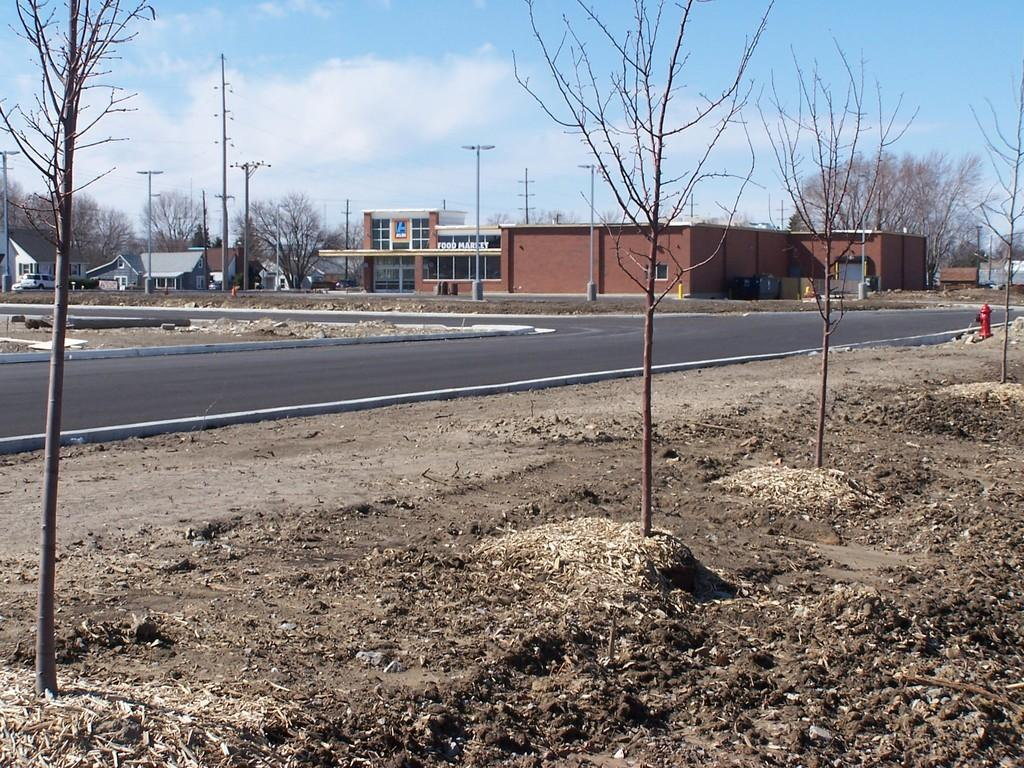What type of vegetation is present on the ground in the image? There are trees on the ground in the image. What type of transportation infrastructure can be seen in the image? There is a road in the image. What type of utility infrastructure is present in the image? There is a hydrant in the image. What type of man-made structures are visible in the image? There are buildings in the image. What type of vertical structures are present in the image? There are poles in the image. What other objects can be seen in the image? There are some objects in the image. What is visible in the background of the image? The sky is visible in the background of the image. Can you hear the bell ringing in the image? There is no bell present in the image, so it cannot be heard. What type of pet is visible in the image? There is no pet present in the image. 